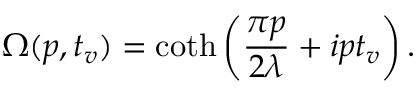<formula> <loc_0><loc_0><loc_500><loc_500>\Omega ( p , t _ { v } ) = \coth \left ( \frac { \pi p } { 2 \lambda } + i p t _ { v } \right ) .</formula> 